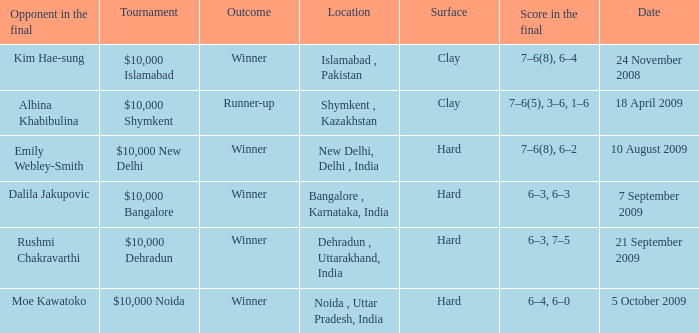What is the material of the surface in the dehradun , uttarakhand, india location Hard. 